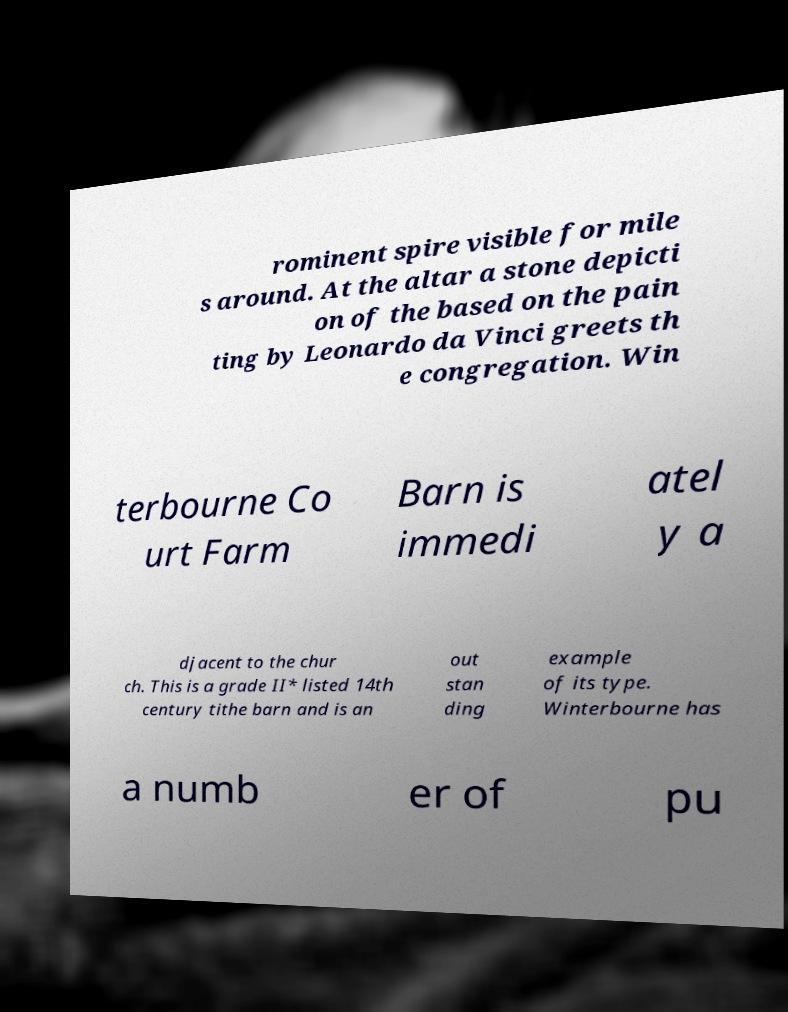Could you extract and type out the text from this image? rominent spire visible for mile s around. At the altar a stone depicti on of the based on the pain ting by Leonardo da Vinci greets th e congregation. Win terbourne Co urt Farm Barn is immedi atel y a djacent to the chur ch. This is a grade II* listed 14th century tithe barn and is an out stan ding example of its type. Winterbourne has a numb er of pu 